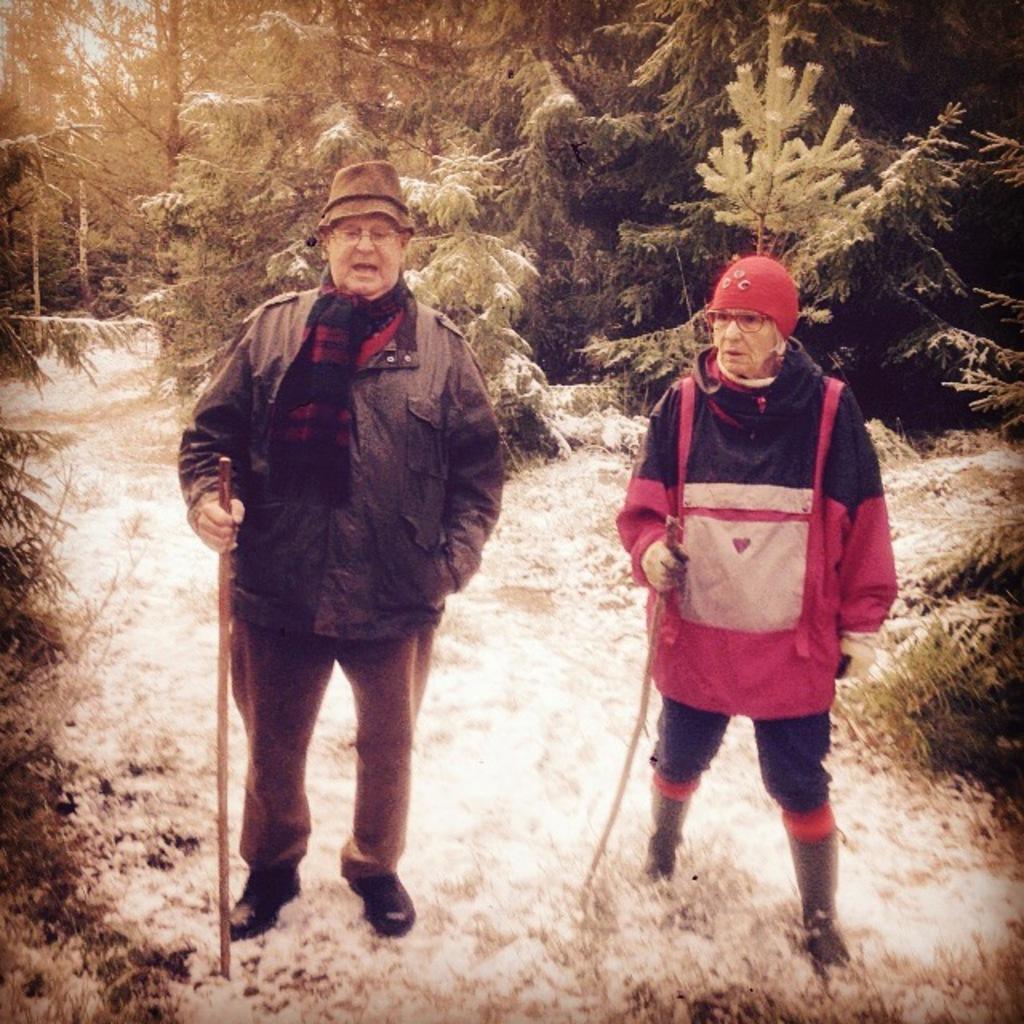In one or two sentences, can you explain what this image depicts? In this picture there are two persons standing and holding a stick in their hands and there are few trees covered with snow in the background. 